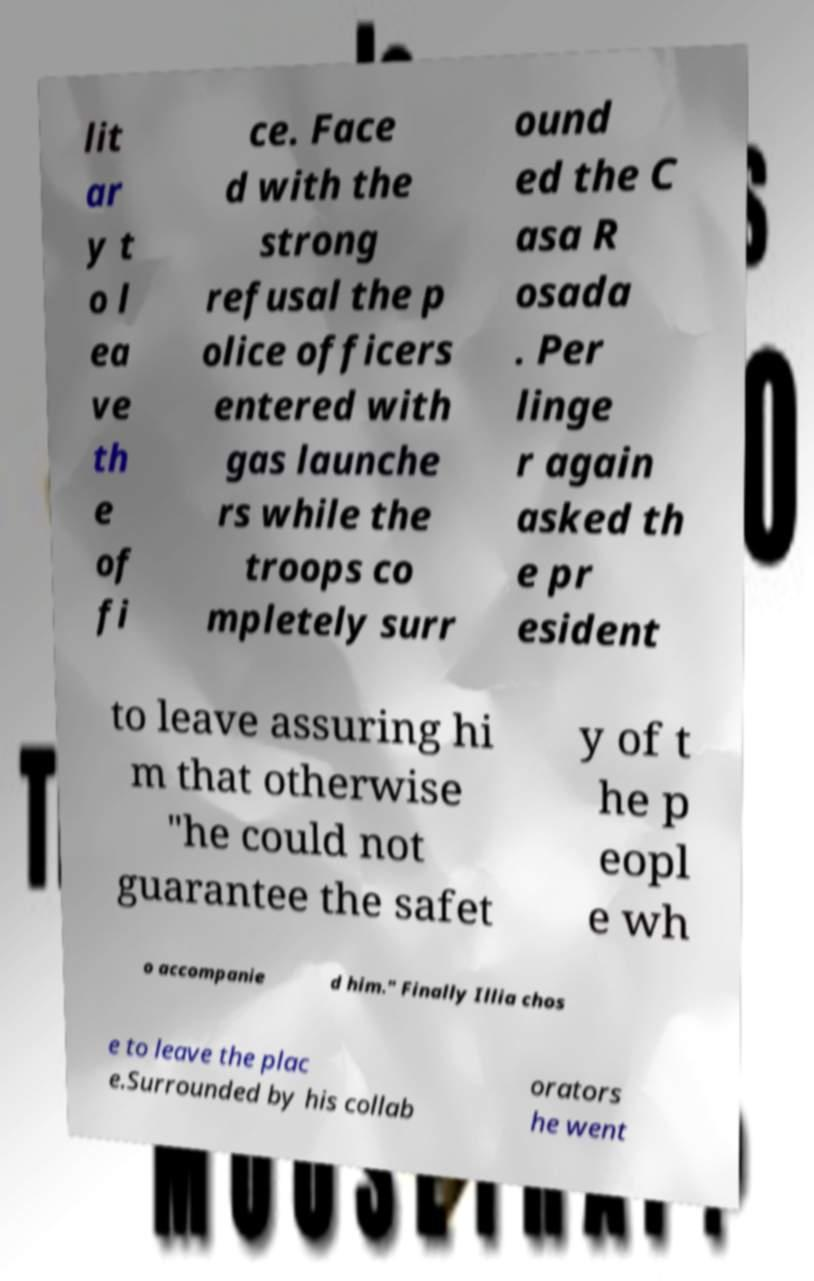There's text embedded in this image that I need extracted. Can you transcribe it verbatim? lit ar y t o l ea ve th e of fi ce. Face d with the strong refusal the p olice officers entered with gas launche rs while the troops co mpletely surr ound ed the C asa R osada . Per linge r again asked th e pr esident to leave assuring hi m that otherwise "he could not guarantee the safet y of t he p eopl e wh o accompanie d him." Finally Illia chos e to leave the plac e.Surrounded by his collab orators he went 